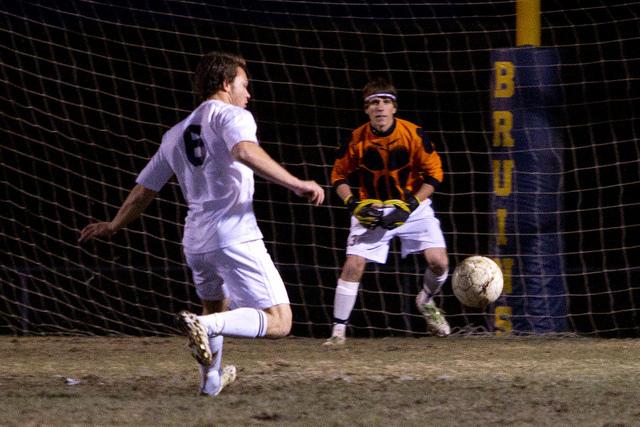What kind of a print is on the man's orange Jersey?
Quick response, please. Paw. What is the man doing with the ball?
Keep it brief. Kicking. What number is the player closest to the ball?
Keep it brief. 6. What color socks are the players wearing?
Be succinct. White. Is the boy in front wearing a watch?
Concise answer only. No. 